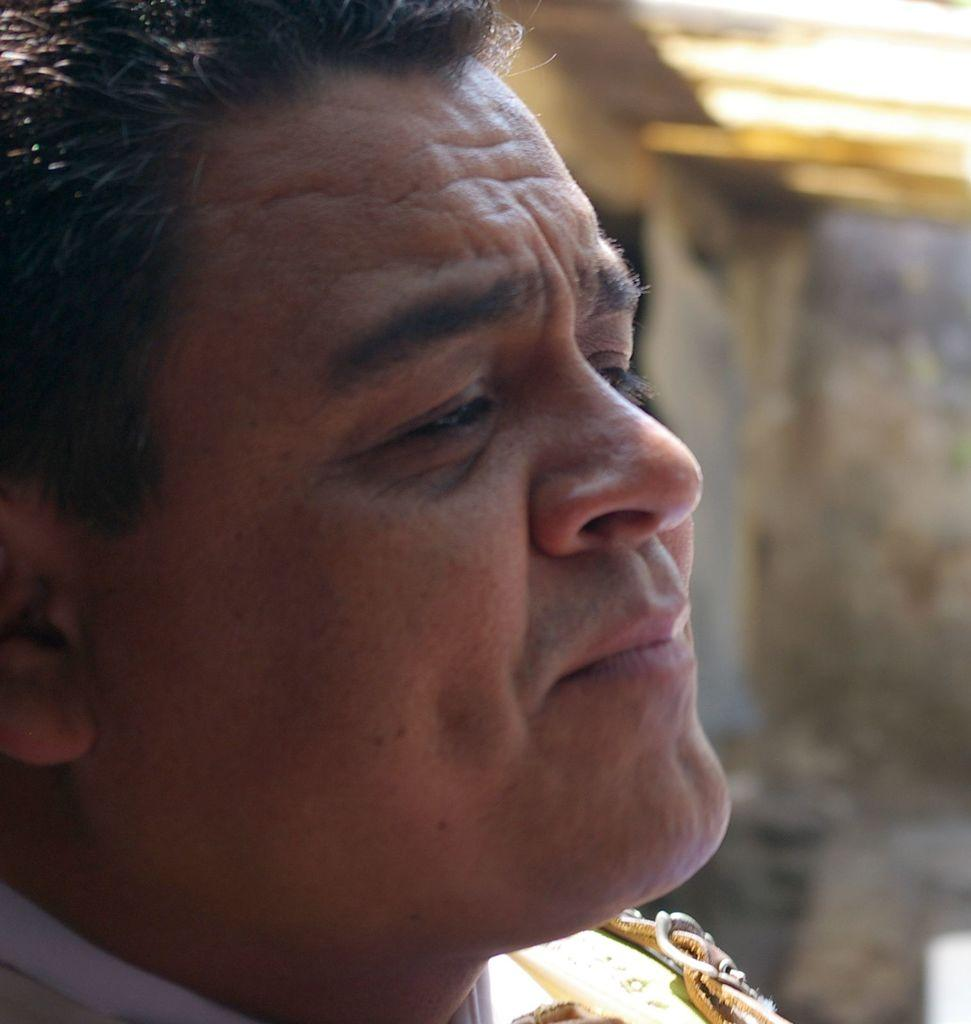Who is present in the image? There is a man in the image. Can you describe the background of the image? Despite the blur, there are objects visible in the background of the image. What type of knee surgery is the man undergoing in the image? There is no indication of a knee surgery or any medical procedure in the image; it simply shows a man with a blurred background. 